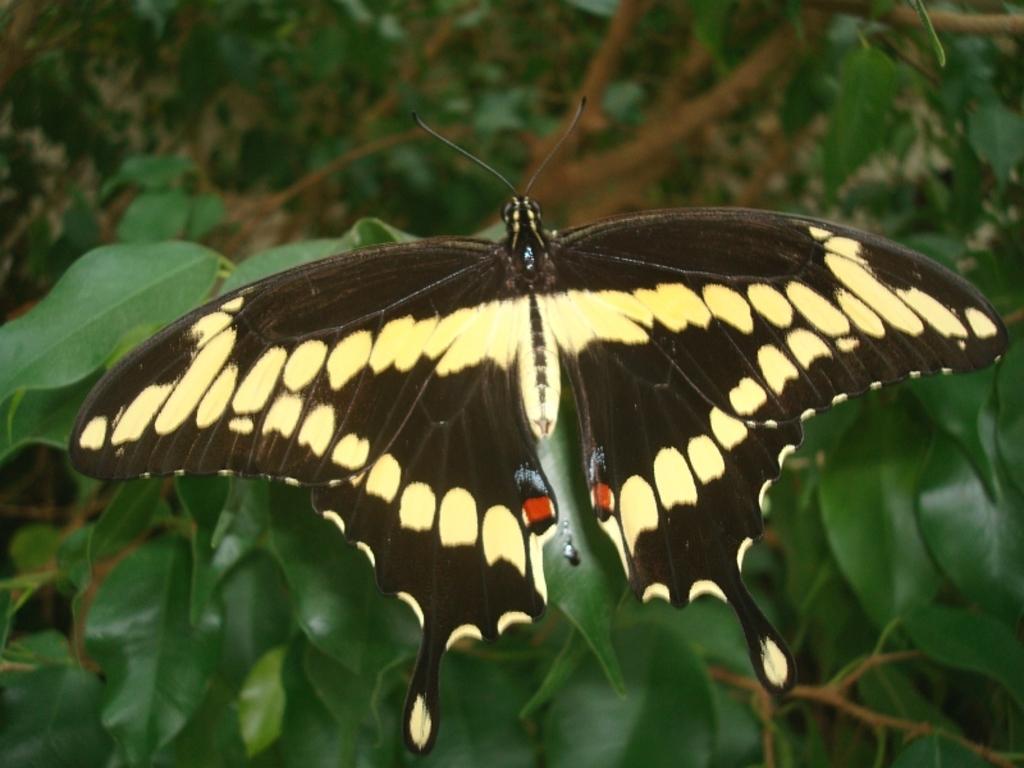How would you summarize this image in a sentence or two? In this image we can see a butterfly which is black and yellow in color and it is flying on the leaves. 